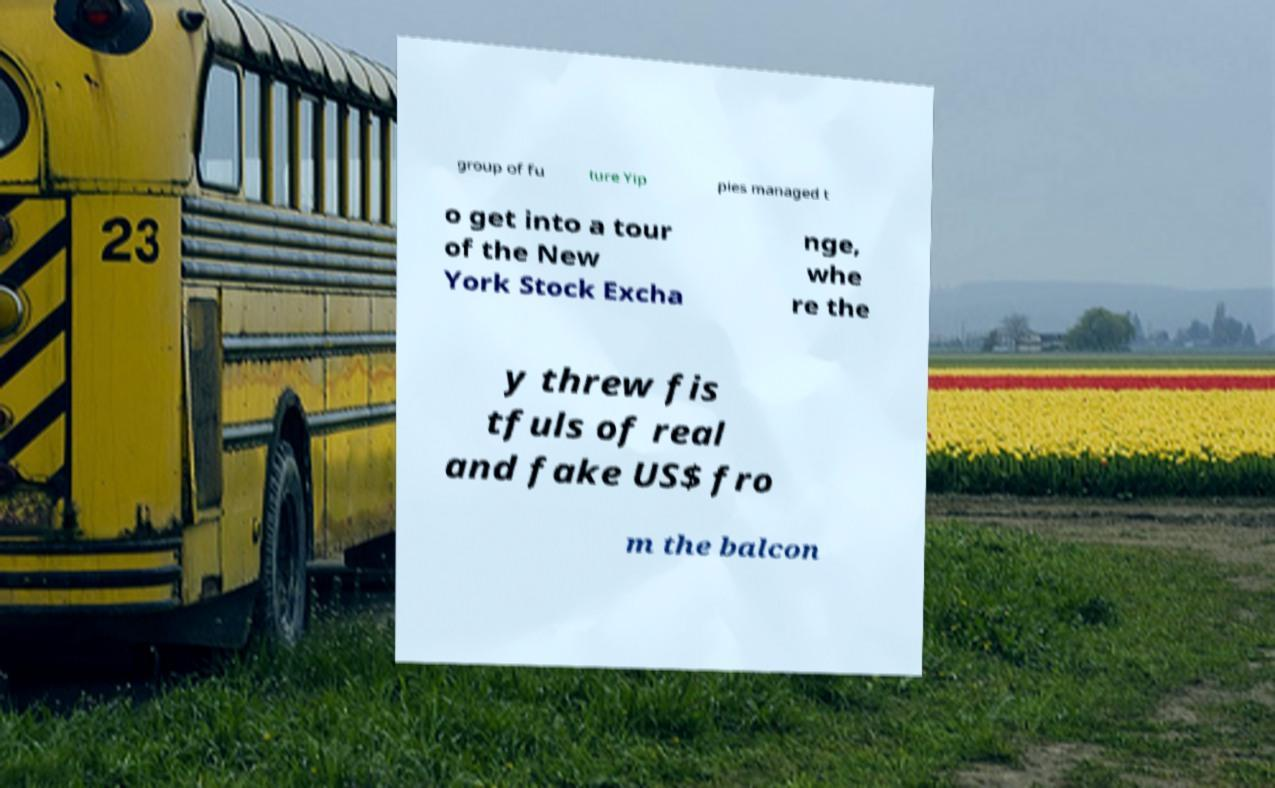What messages or text are displayed in this image? I need them in a readable, typed format. group of fu ture Yip pies managed t o get into a tour of the New York Stock Excha nge, whe re the y threw fis tfuls of real and fake US$ fro m the balcon 